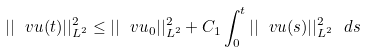<formula> <loc_0><loc_0><loc_500><loc_500>| | \ v u ( t ) | | ^ { 2 } _ { L ^ { 2 } } \leq | | \ v u _ { 0 } | | ^ { 2 } _ { L ^ { 2 } } + C _ { 1 } \int _ { 0 } ^ { t } | | \ v u ( s ) | | ^ { 2 } _ { L ^ { 2 } } \ d s</formula> 